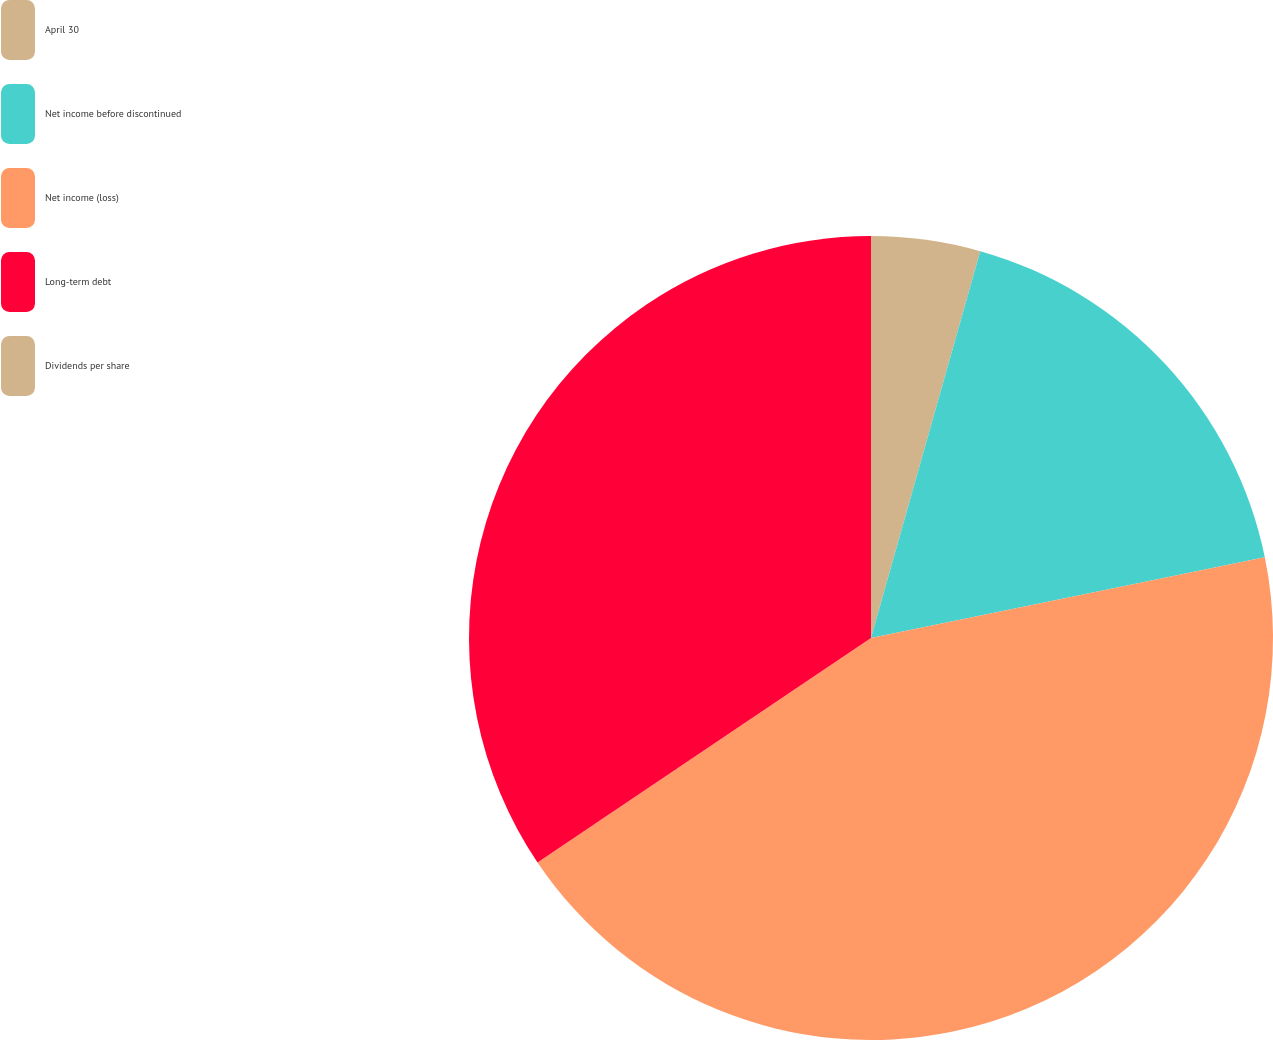Convert chart. <chart><loc_0><loc_0><loc_500><loc_500><pie_chart><fcel>April 30<fcel>Net income before discontinued<fcel>Net income (loss)<fcel>Long-term debt<fcel>Dividends per share<nl><fcel>4.38%<fcel>17.4%<fcel>43.79%<fcel>34.43%<fcel>0.0%<nl></chart> 